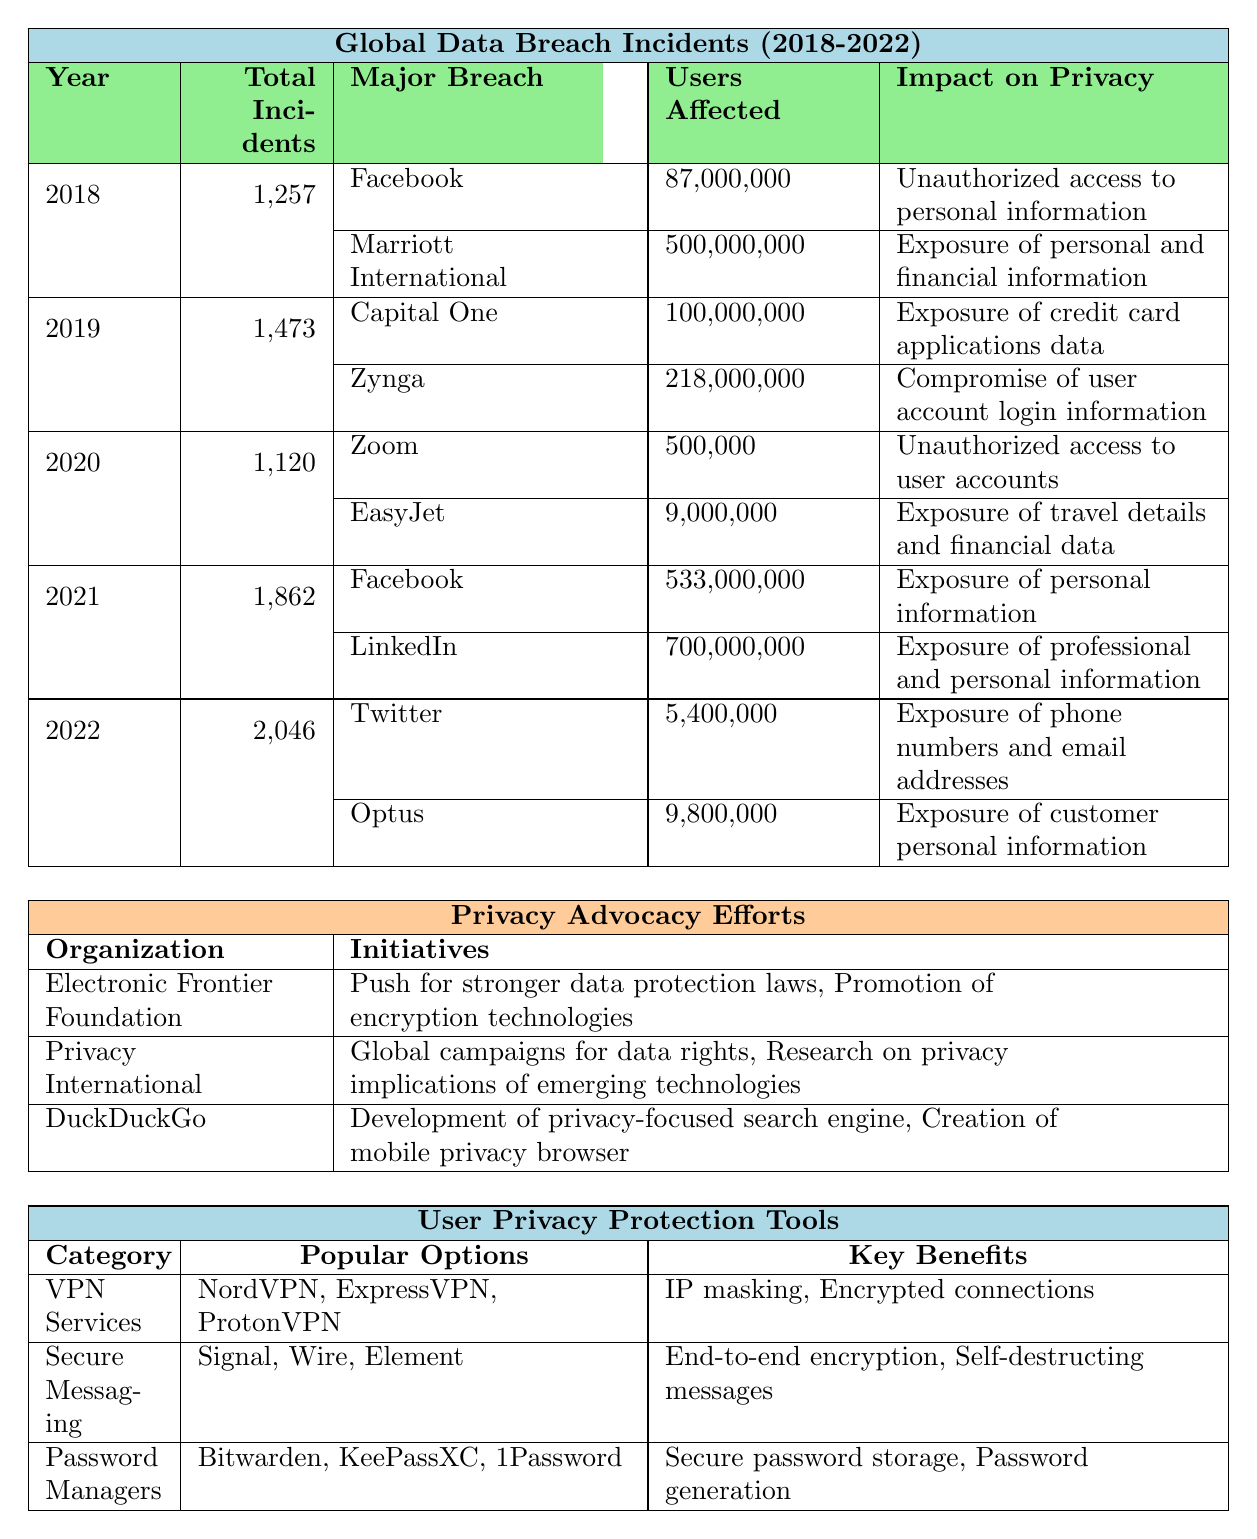What was the total number of data breach incidents in 2020? In the table, under the year 2020, the total number of incidents is explicitly stated. The total for that year is 1,120.
Answer: 1,120 Which company had the largest number of users affected by a data breach in 2019? By examining the major breaches listed for 2019, Zynga is noted to have 218 million users affected, while Capital One had 100 million. Thus, Zynga had the largest number.
Answer: Zynga What types of data breaches are listed for the year 2021? The table lists the major breaches for 2021, which are categorized as both "Data Scraping" for Facebook and LinkedIn.
Answer: Data Scraping How many total incidents occurred from 2018 to 2022? To find the total incidents, we need to sum the incidents from each year: 1,257 (2018) + 1,473 (2019) + 1,120 (2020) + 1,862 (2021) + 2,046 (2022) = 7,758.
Answer: 7,758 Did any of the major breaches in 2020 affect more than 10 million users? Looking at the data for 2020, Zoom affected 500,000 users and EasyJet affected 9 million. Both figures are below 10 million; therefore, no breaches exceeded that threshold.
Answer: No In which year was the highest total number of incidents recorded? By reviewing the total incidents by year, we see that 2022 has the highest total at 2,046 incidents, followed by other years.
Answer: 2022 Which sector was most affected by data breaches in 2018? The most affected sectors in 2018 were listed as Social Media, Hospitality, and Healthcare, with Social Media being a prominent one.
Answer: Social Media What was the average number of users affected per incident across all years? First, calculate the total users affected for major breaches across all years and then divide by the total number of incidents: (87M + 500M + 100M + 218M + 500K + 9M + 533M + 700M + 5.4M + 9.8M) / 7,758 incidents gives the average. After calculation, it comes to approximately 106 million.
Answer: Approximately 106 million Which organization is known for advocating stronger data protection laws? Reviewing the privacy advocacy efforts, the Electronic Frontier Foundation is explicitly mentioned for pushing for stronger data protection laws.
Answer: Electronic Frontier Foundation How many organizations are listed for privacy advocacy efforts? The table lists three organizations: Electronic Frontier Foundation, Privacy International, and DuckDuckGo. Thus, there are three organizations.
Answer: Three 